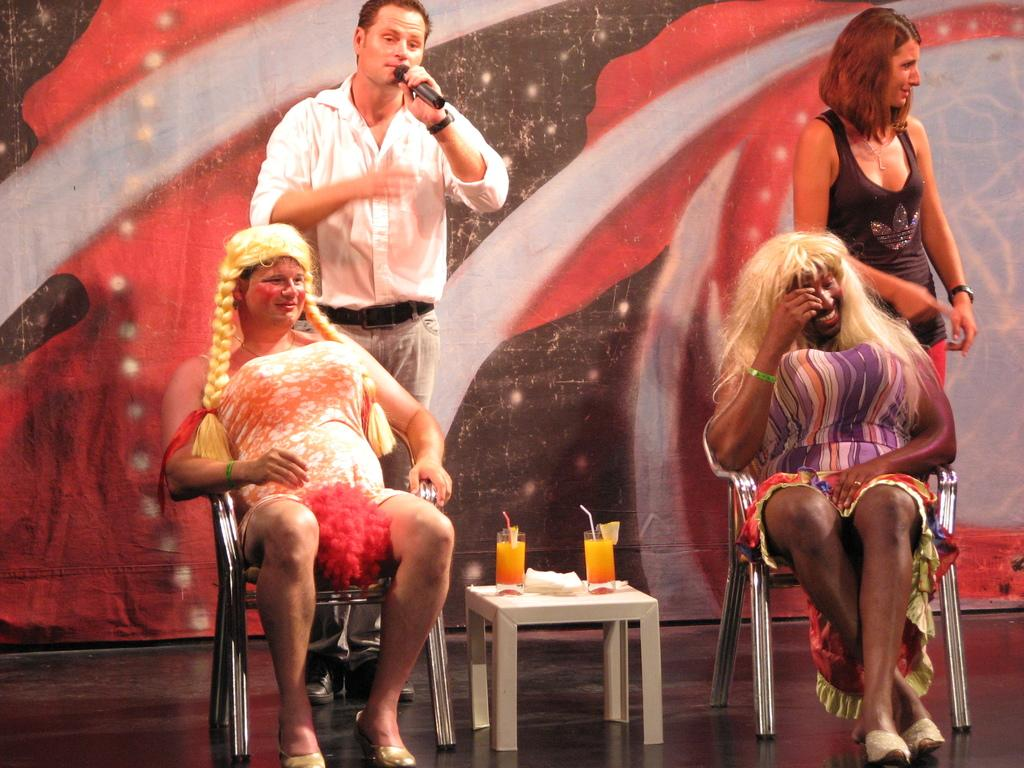What is happening in the foreground of the picture? There are people on stage in the foreground of the picture. What furniture is present on stage? There are chairs and a table on stage. What items can be seen on stage besides furniture? Drinks and tissues are visible on stage. Can you describe the woman on stage? There is a woman on stage. What is visible in the background of the picture? There is a curtain in the background of the picture. What type of meat is being served on stage in the image? There is no meat present in the image; it features people on stage with chairs, a table, drinks, and tissues. Can you tell me how many clams are visible on stage? There are no clams present in the image. 